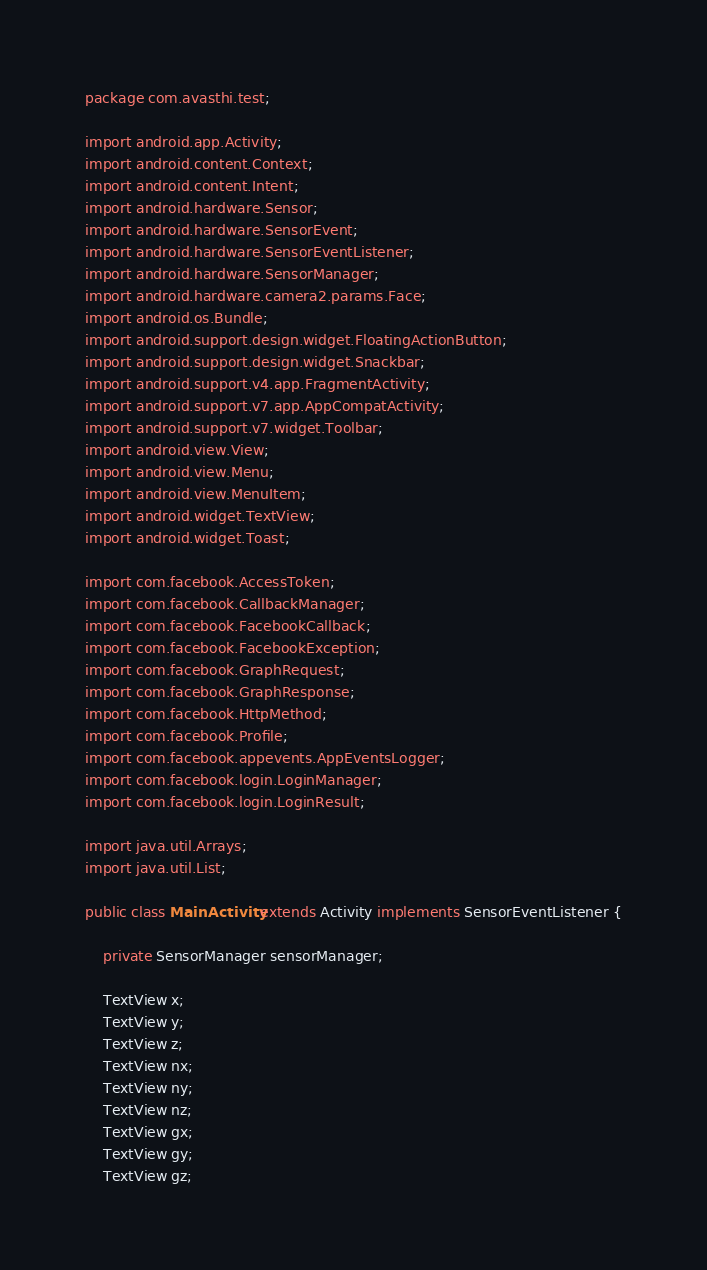<code> <loc_0><loc_0><loc_500><loc_500><_Java_>package com.avasthi.test;

import android.app.Activity;
import android.content.Context;
import android.content.Intent;
import android.hardware.Sensor;
import android.hardware.SensorEvent;
import android.hardware.SensorEventListener;
import android.hardware.SensorManager;
import android.hardware.camera2.params.Face;
import android.os.Bundle;
import android.support.design.widget.FloatingActionButton;
import android.support.design.widget.Snackbar;
import android.support.v4.app.FragmentActivity;
import android.support.v7.app.AppCompatActivity;
import android.support.v7.widget.Toolbar;
import android.view.View;
import android.view.Menu;
import android.view.MenuItem;
import android.widget.TextView;
import android.widget.Toast;

import com.facebook.AccessToken;
import com.facebook.CallbackManager;
import com.facebook.FacebookCallback;
import com.facebook.FacebookException;
import com.facebook.GraphRequest;
import com.facebook.GraphResponse;
import com.facebook.HttpMethod;
import com.facebook.Profile;
import com.facebook.appevents.AppEventsLogger;
import com.facebook.login.LoginManager;
import com.facebook.login.LoginResult;

import java.util.Arrays;
import java.util.List;

public class MainActivity extends Activity implements SensorEventListener {

    private SensorManager sensorManager;

    TextView x;
    TextView y;
    TextView z;
    TextView nx;
    TextView ny;
    TextView nz;
    TextView gx;
    TextView gy;
    TextView gz;</code> 